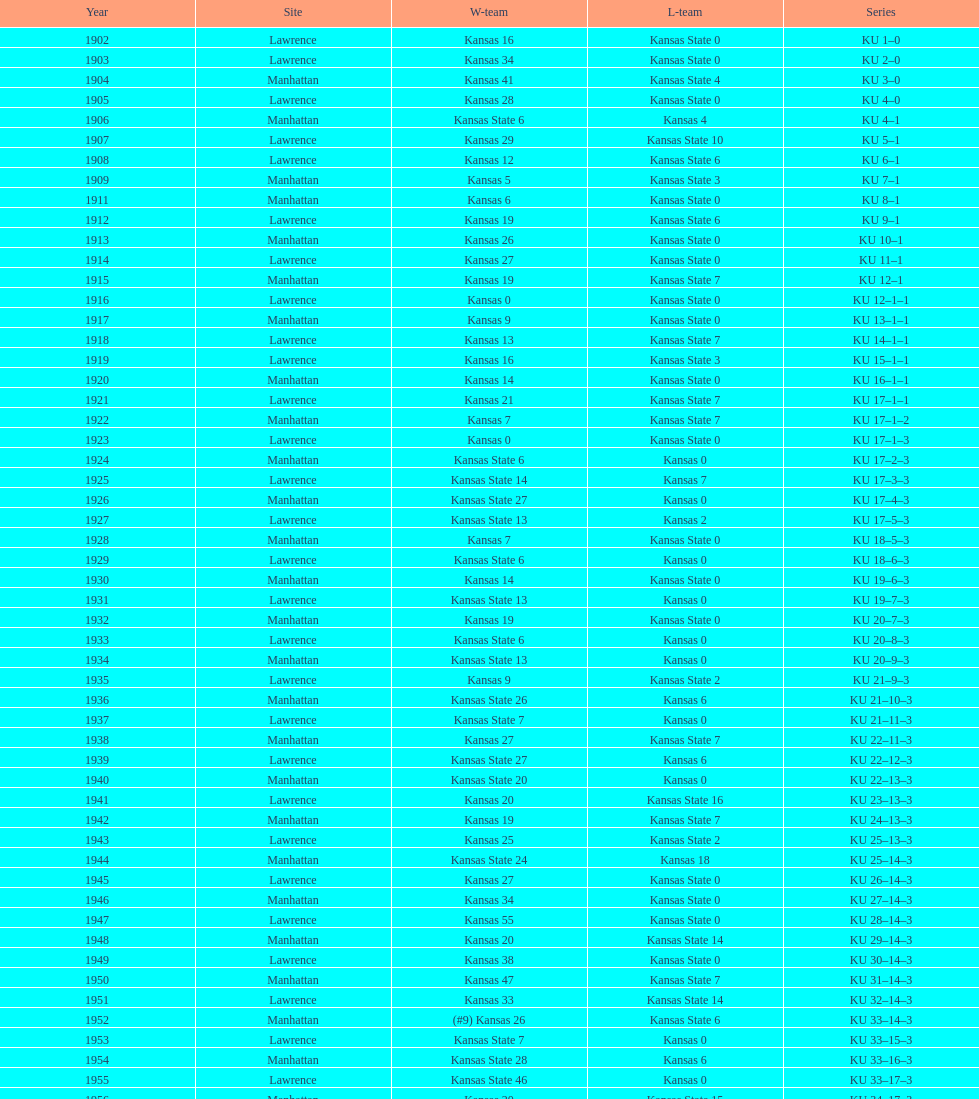How many times did kansas and kansas state play in lawrence from 1902-1968? 34. 